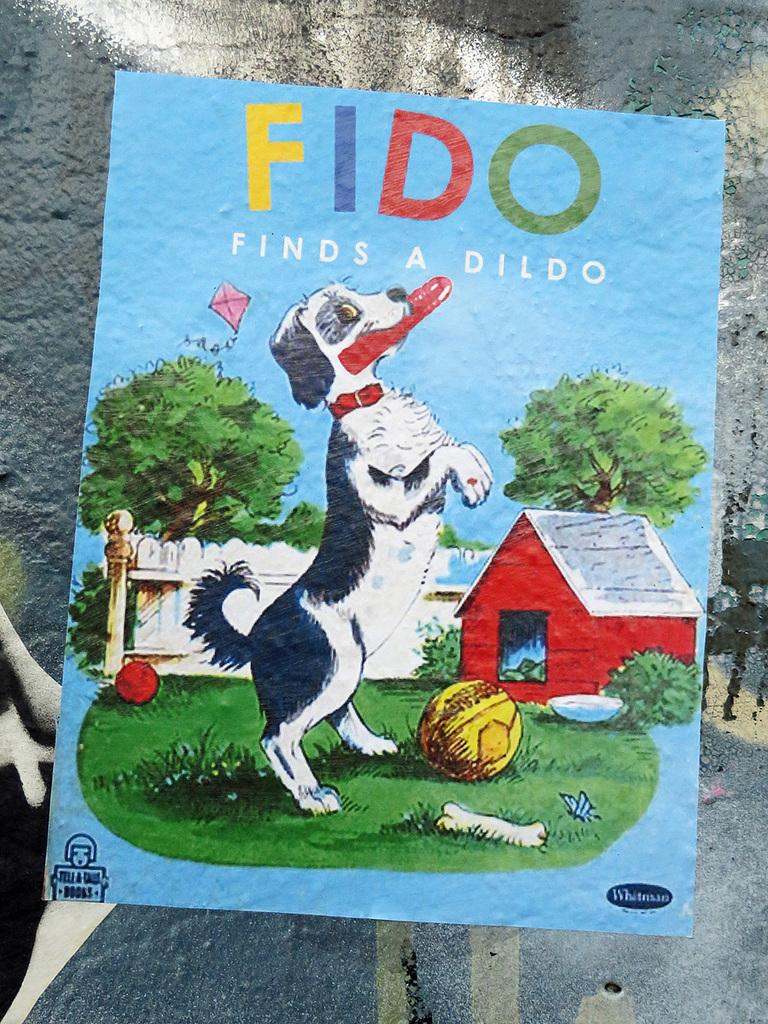What is depicted in the painting in the image? There is a painting of a dog in the image. What objects are on the ground in the image? There are two balls on the ground in the image. What can be seen in the background of the image? There is a building, a group of trees, and some text visible in the background of the image. What type of jam is being spread on the chicken in the image? There is no jam or chicken present in the image; it features a painting of a dog and objects on the ground. Where is the sink located in the image? There is no sink present in the image. 